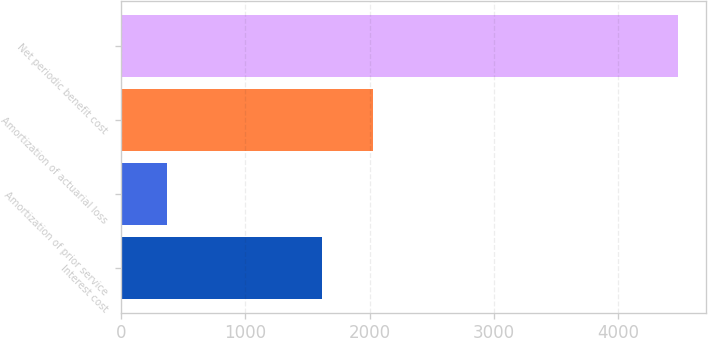<chart> <loc_0><loc_0><loc_500><loc_500><bar_chart><fcel>Interest cost<fcel>Amortization of prior service<fcel>Amortization of actuarial loss<fcel>Net periodic benefit cost<nl><fcel>1614<fcel>371<fcel>2025<fcel>4481<nl></chart> 